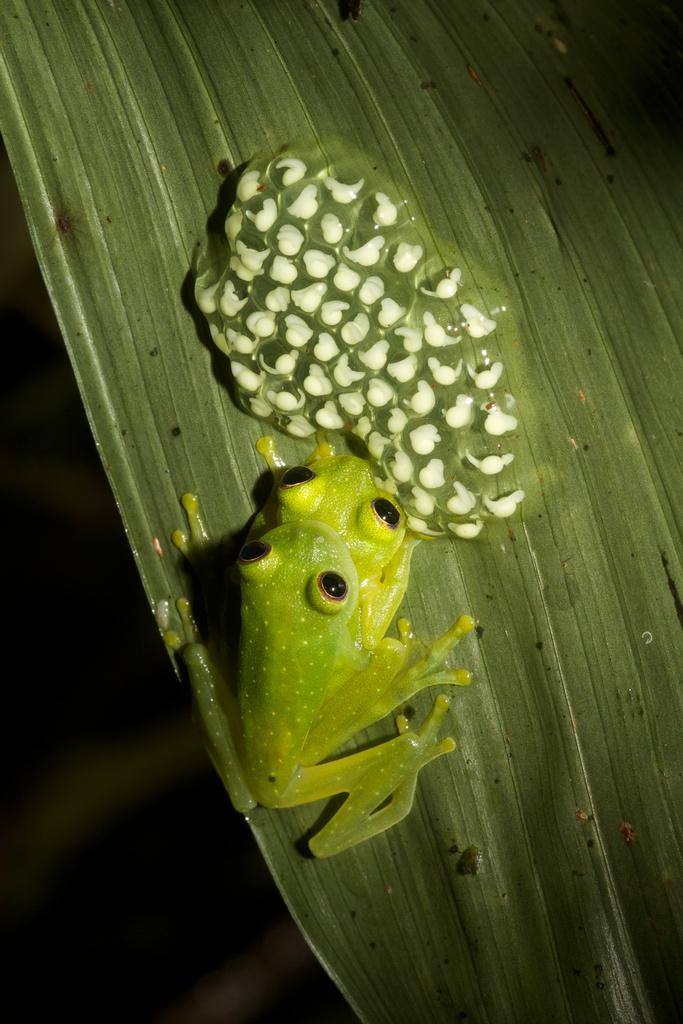What animal is present in the image? There is a frog in the image. Where is the frog located? The frog is sitting on a leaf. What type of control system is visible in the image? There is no control system present in the image; it features a frog sitting on a leaf. What type of thing is the frog interacting with in the image? The frog is not interacting with any specific thing in the image; it is simply sitting on a leaf. 